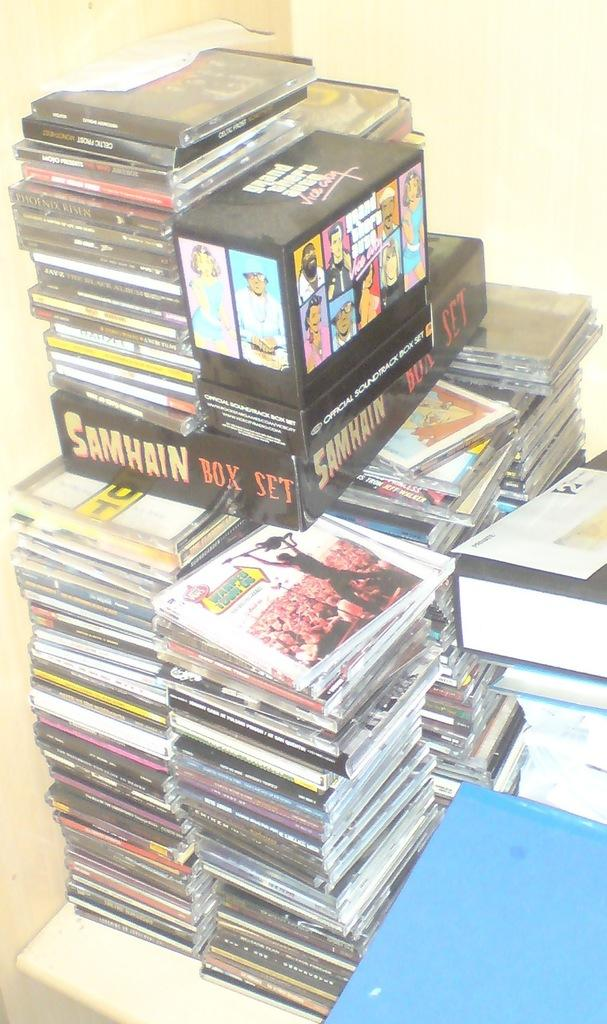<image>
Give a short and clear explanation of the subsequent image. A Samhain Box Set sits on top of many CDs. 